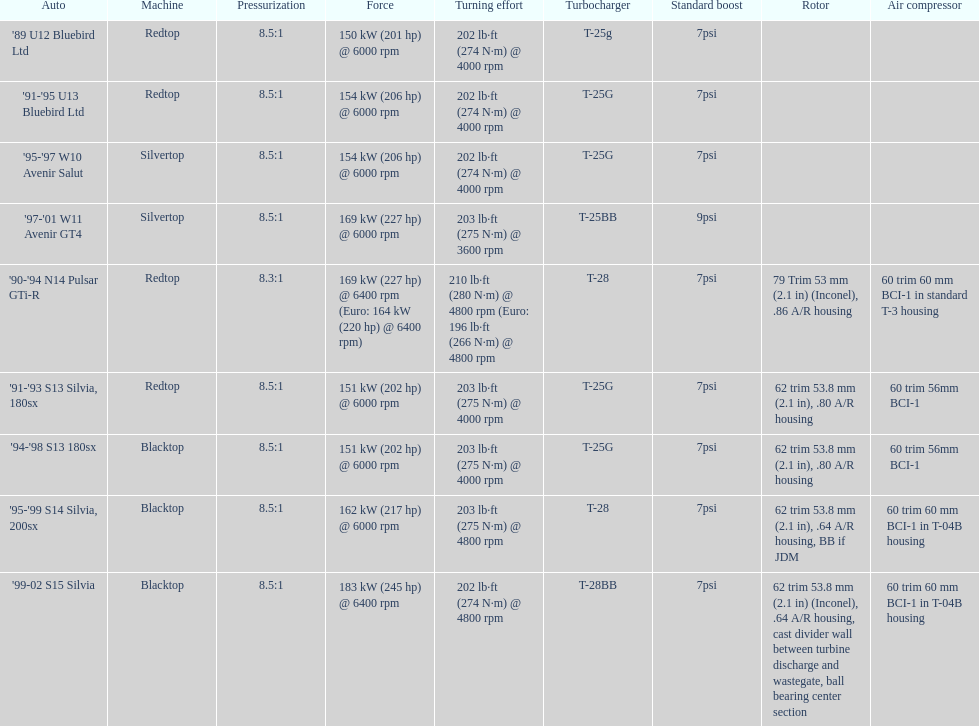How many models used the redtop engine? 4. 